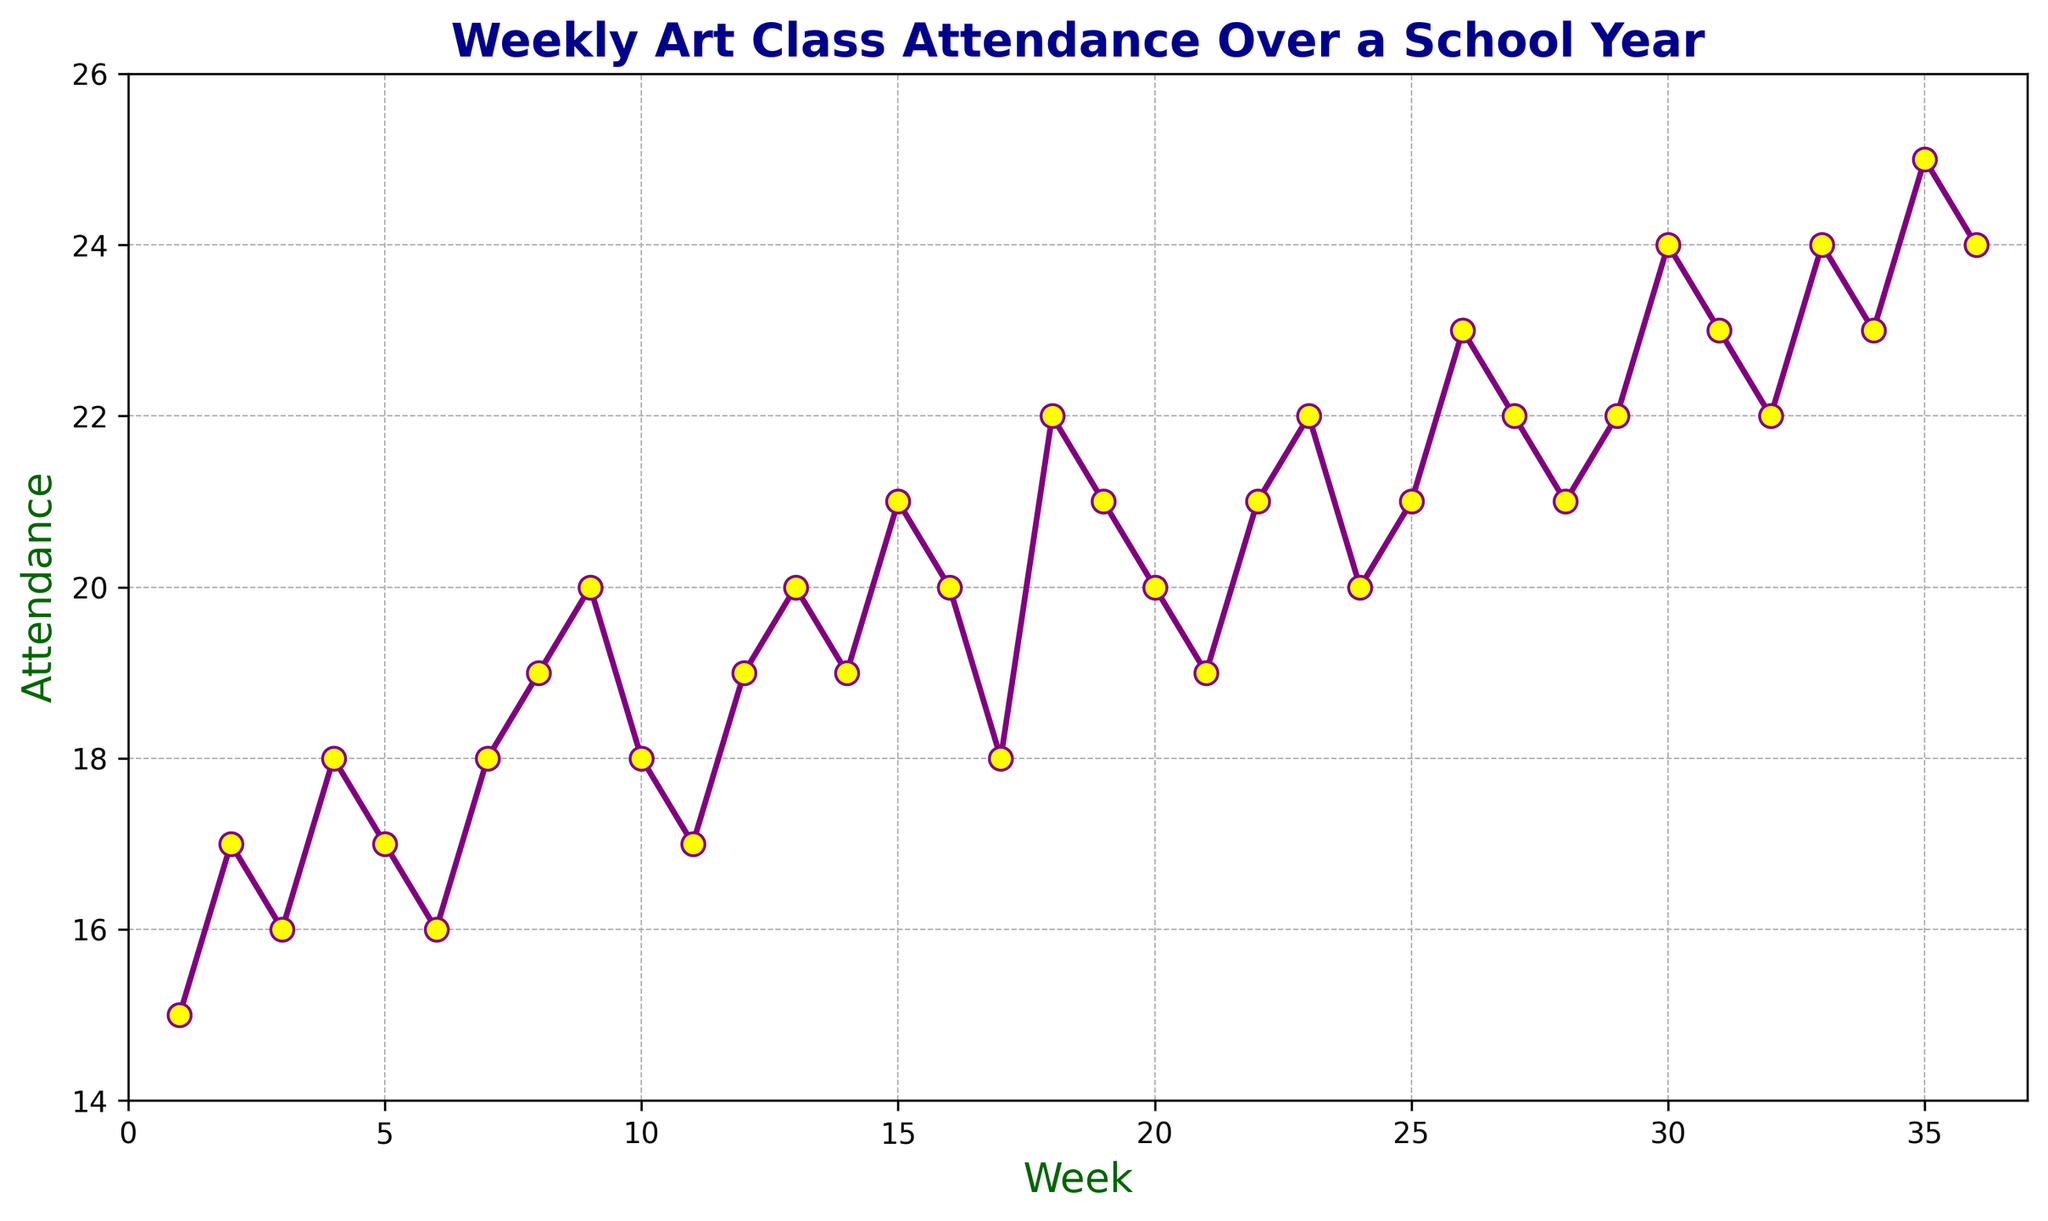what's the average weekly attendance in the first 5 weeks? To find the average attendance in the first 5 weeks, sum the attendance figures for weeks 1 to 5: 15 + 17 + 16 + 18 + 17 = 83. Then divide by the number of weeks, 5. So, 83 / 5 = 16.6
Answer: 16.6 how much did the attendance increase between week 1 and week 30? Look at the attendance for week 1, which is 15, and for week 30, which is 24. The increase can be found by subtracting the week 1 attendance from the week 30 attendance: 24 - 15 = 9
Answer: 9 which week had the highest attendance? Check the data visually for the highest point on the chart to find that week 35 had the highest attendance of 25
Answer: 35 are there any weeks with the same attendance and what is that value? Look for points on the chart that align horizontally. Both weeks 9 and 12 have an attendance of 20, and so do weeks 22 and 28 with an attendance of 21.
Answer: 20 and 21 did the attendance ever decrease for two consecutive weeks? Examine the line for any downward slopes over two consecutive weeks. Yes, from week 10 (18) to week 11 (17) to week 12 (19) it decreased for two weeks in a row where it decreased from 10 to 11.
Answer: yes what's the difference between the highest and lowest attendance values? Find the highest and lowest attendance values: the highest is 25 (week 35) and the lowest is 15 (week 1). Subtract the lowest from the highest: 25 - 15 = 10
Answer: 10 how many weeks had attendance greater than 20? Count the points on the chart that are above 20. The weeks are 18, 19, 22, 23, 25, 26, 27, 29, 30, 31, 33, 34, 35, 36, totaling 14 weeks
Answer: 14 when did attendance first reach 20? Identify the first week where the attendance reaches 20. This occurs in week 9.
Answer: week 9 